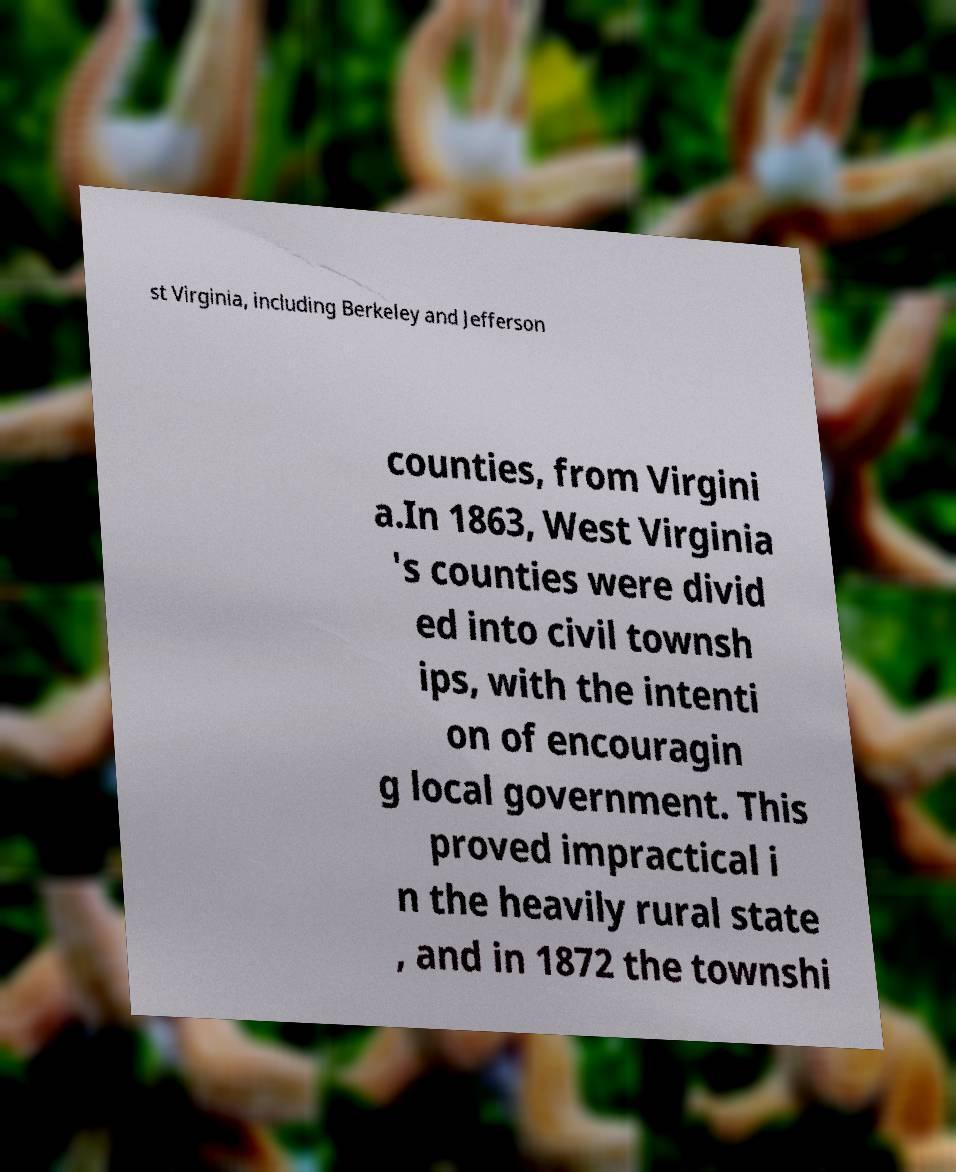Can you read and provide the text displayed in the image?This photo seems to have some interesting text. Can you extract and type it out for me? st Virginia, including Berkeley and Jefferson counties, from Virgini a.In 1863, West Virginia 's counties were divid ed into civil townsh ips, with the intenti on of encouragin g local government. This proved impractical i n the heavily rural state , and in 1872 the townshi 